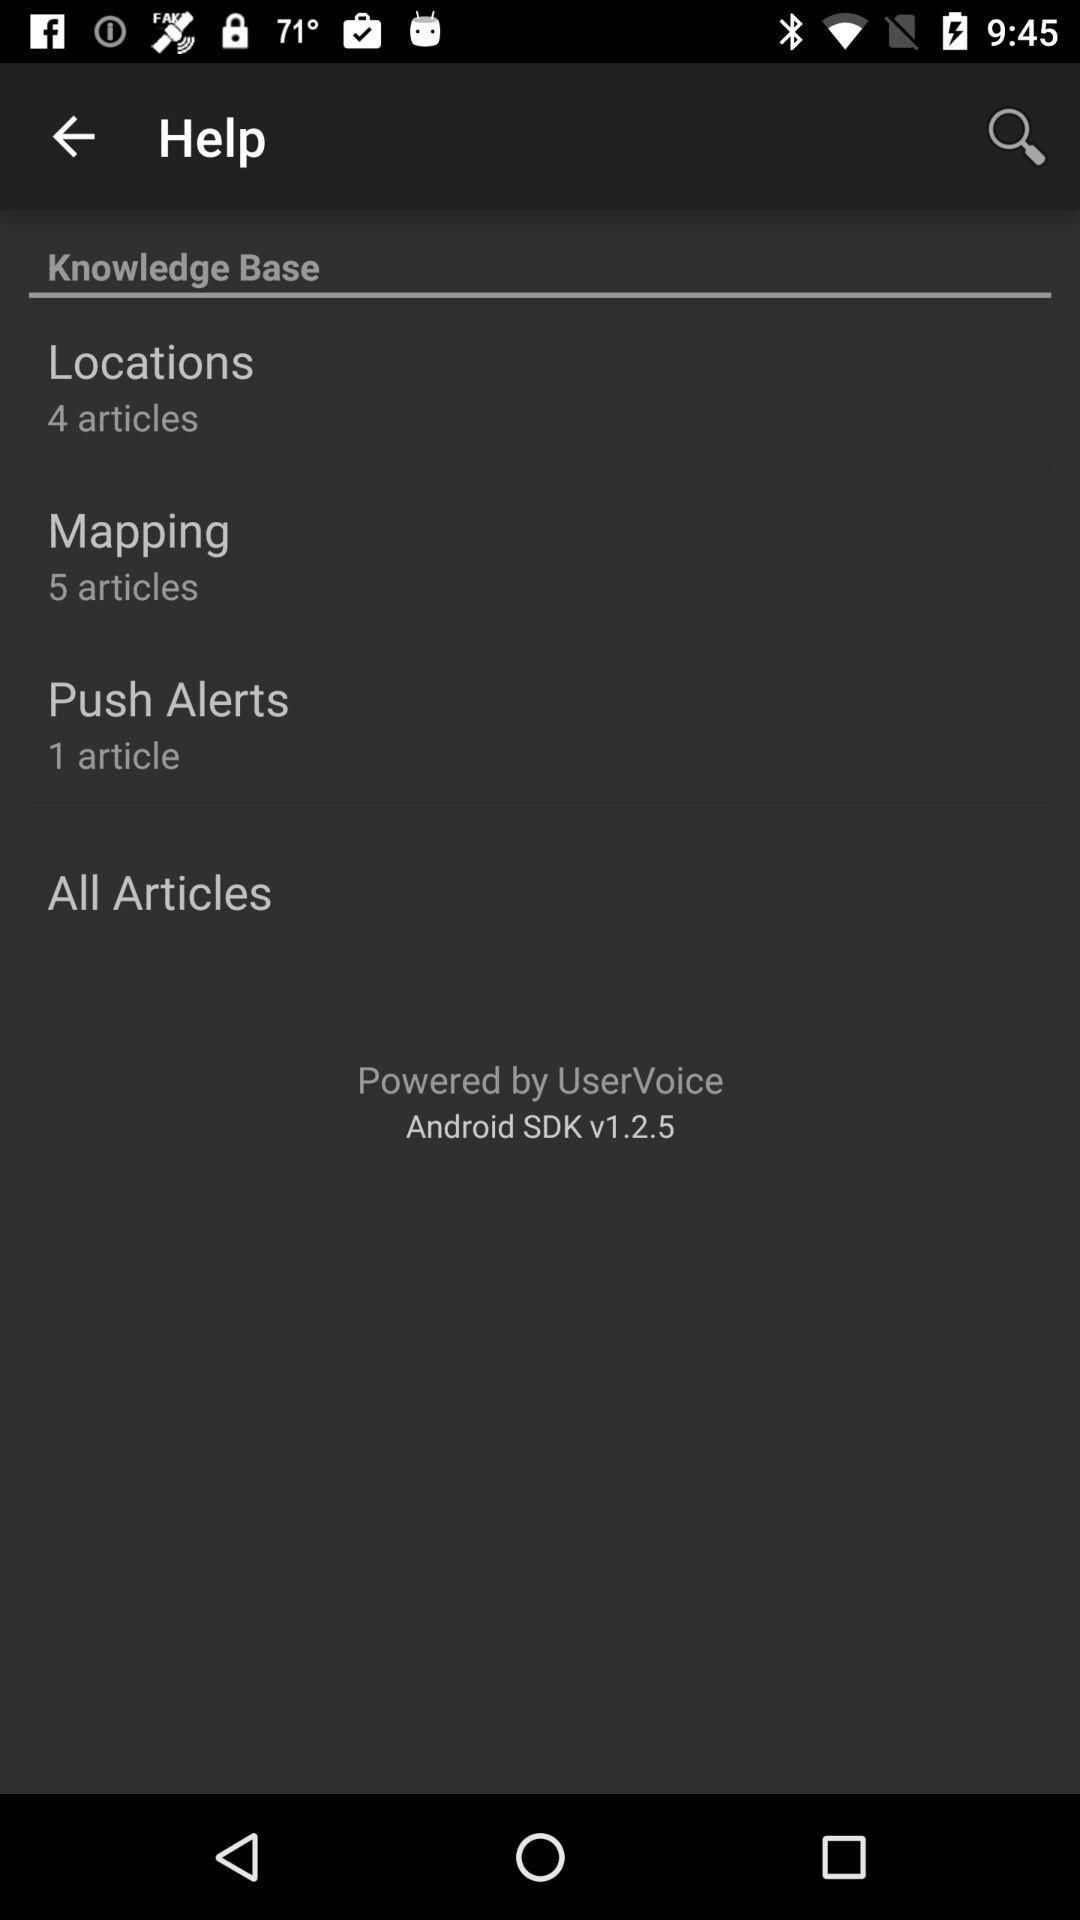What is the current version? The current version is v1.2.5. 